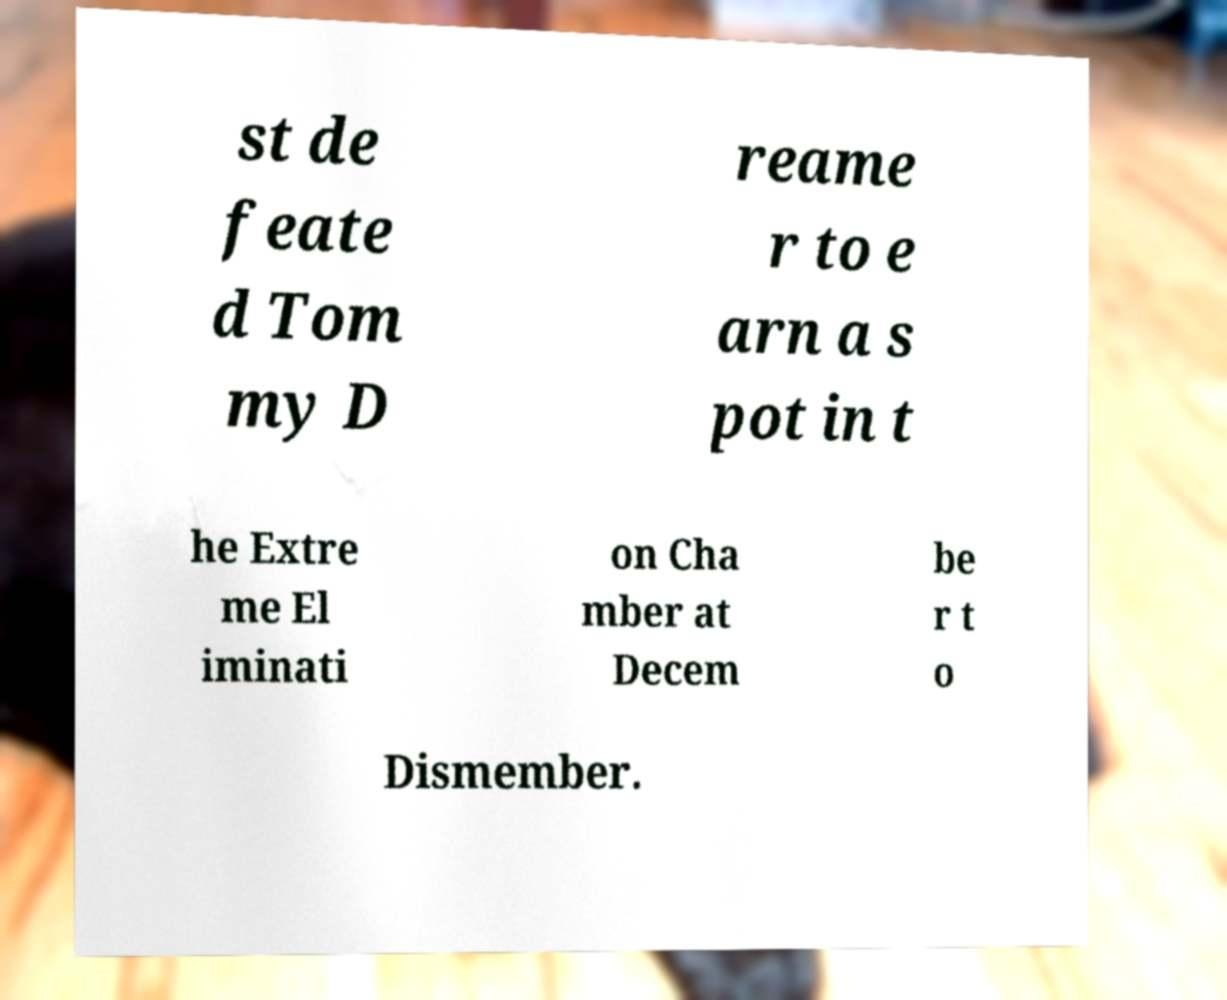Could you assist in decoding the text presented in this image and type it out clearly? st de feate d Tom my D reame r to e arn a s pot in t he Extre me El iminati on Cha mber at Decem be r t o Dismember. 